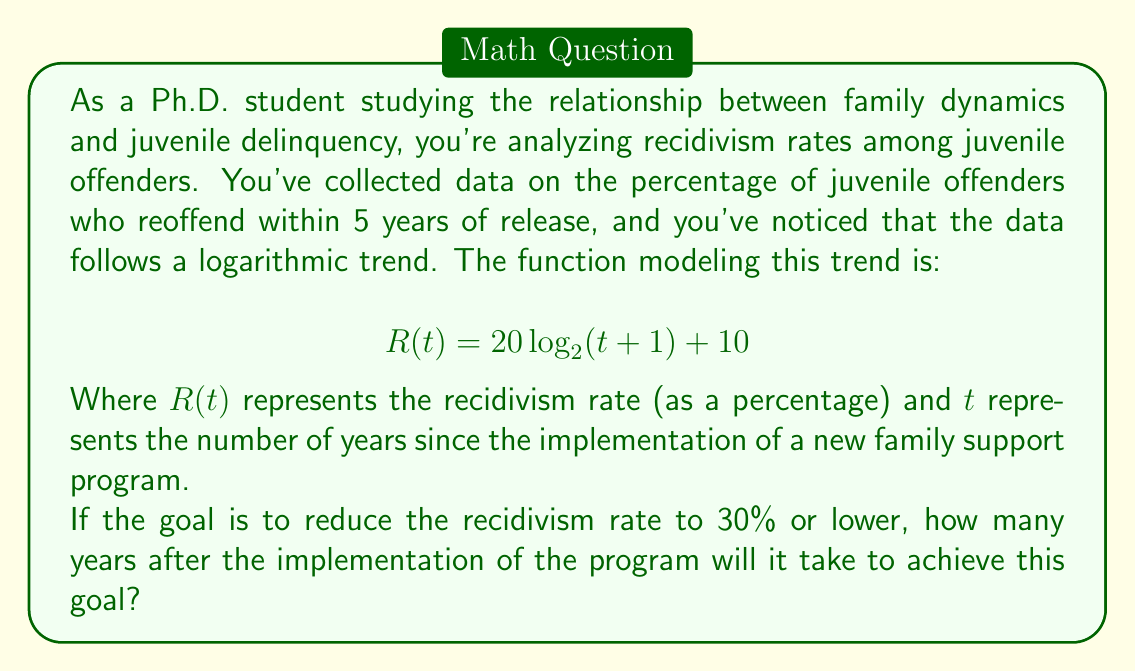Show me your answer to this math problem. To solve this problem, we need to use the given logarithmic function and solve for $t$ when $R(t) = 30$. Let's approach this step-by-step:

1) We start with the equation:
   $$ R(t) = 20 \log_{2}(t+1) + 10 $$

2) We want to find $t$ when $R(t) = 30$, so let's substitute this:
   $$ 30 = 20 \log_{2}(t+1) + 10 $$

3) Subtract 10 from both sides:
   $$ 20 = 20 \log_{2}(t+1) $$

4) Divide both sides by 20:
   $$ 1 = \log_{2}(t+1) $$

5) Now, we need to apply the inverse function (exponential) to both sides. Since the base of the logarithm is 2, we'll use 2 as the base of our exponential:
   $$ 2^1 = 2^{\log_{2}(t+1)} $$

6) The left side simplifies to 2, and the exponent and logarithm on the right side cancel out:
   $$ 2 = t+1 $$

7) Subtract 1 from both sides to isolate $t$:
   $$ 1 = t $$

Therefore, it will take 1 year after the implementation of the program to reduce the recidivism rate to 30%.

To verify, we can plug this value back into the original equation:
$$ R(1) = 20 \log_{2}(1+1) + 10 = 20 \log_{2}(2) + 10 = 20(1) + 10 = 30 $$

This confirms our solution.
Answer: It will take 1 year after the implementation of the family support program to reduce the recidivism rate to 30%. 